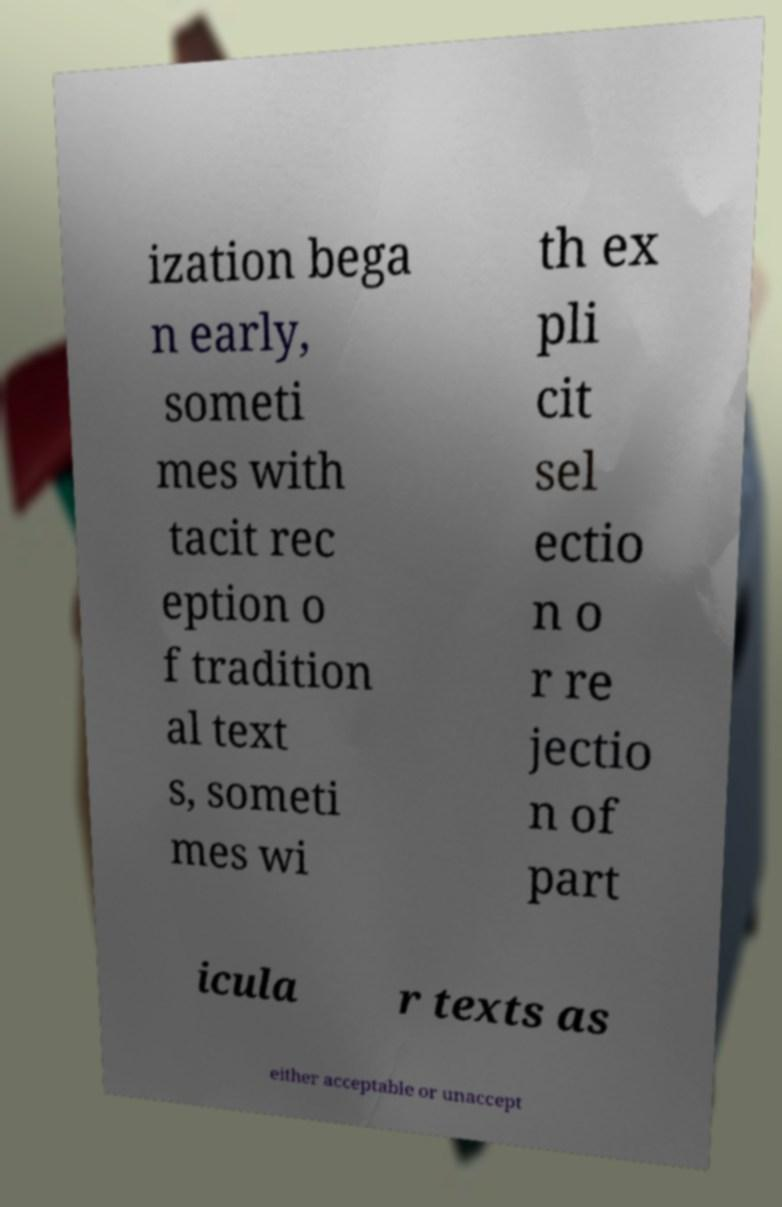Could you extract and type out the text from this image? ization bega n early, someti mes with tacit rec eption o f tradition al text s, someti mes wi th ex pli cit sel ectio n o r re jectio n of part icula r texts as either acceptable or unaccept 